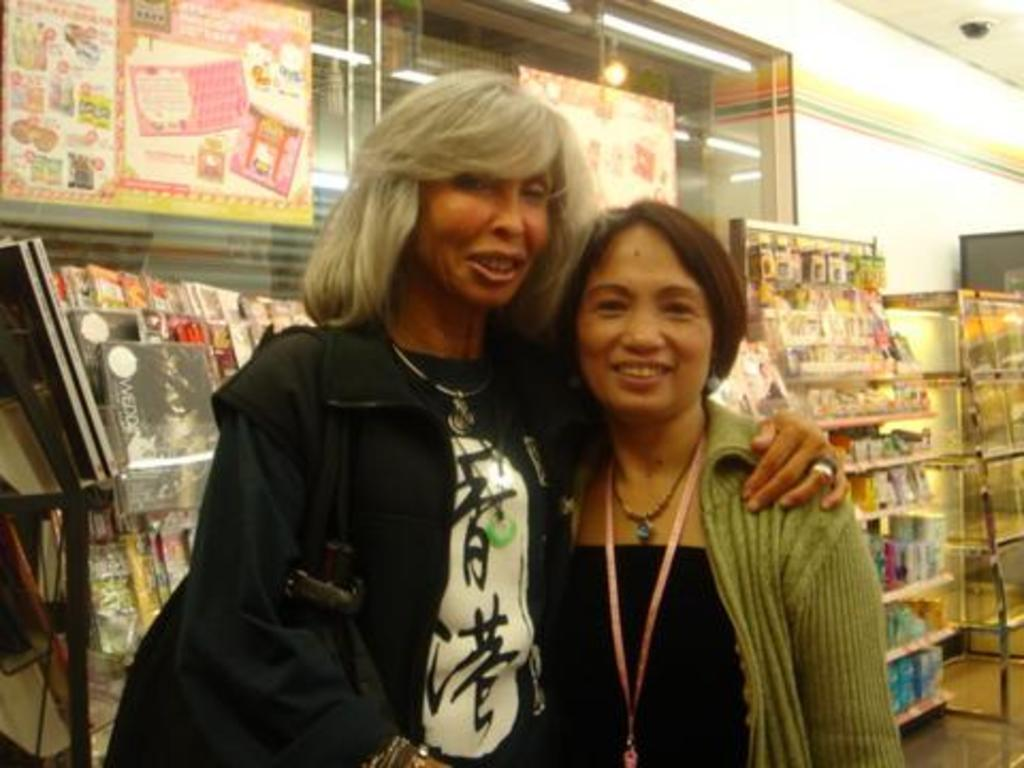How many women are in the image? There are two women in the image. What expression do the women have? The women are smiling. What type of reading material can be seen in the image? There are magazines visible in the image. What else can be seen in the aisles in the image? There are other objects in the aisles in the image. What type of lock can be seen securing the field in the image? There is no field or lock present in the image. What branch of the tree is closest to the women in the image? There is no tree or branch present in the image. 